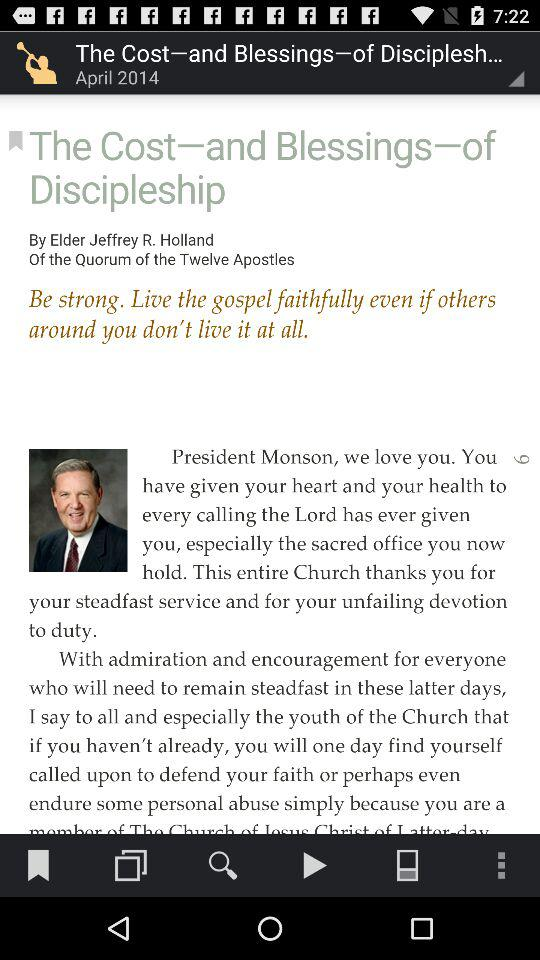When was the blog published? The blog was published in April 2014. 